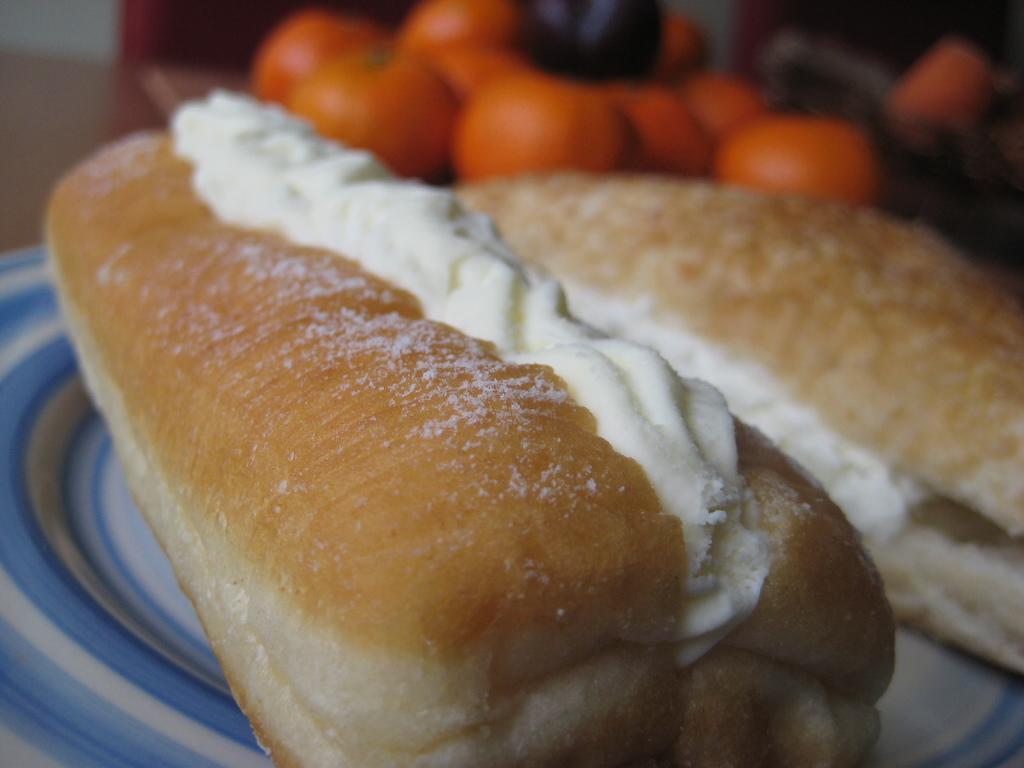How would you summarize this image in a sentence or two? There are two hot dog buns with cream on a plate. In the background there are orange color items. 